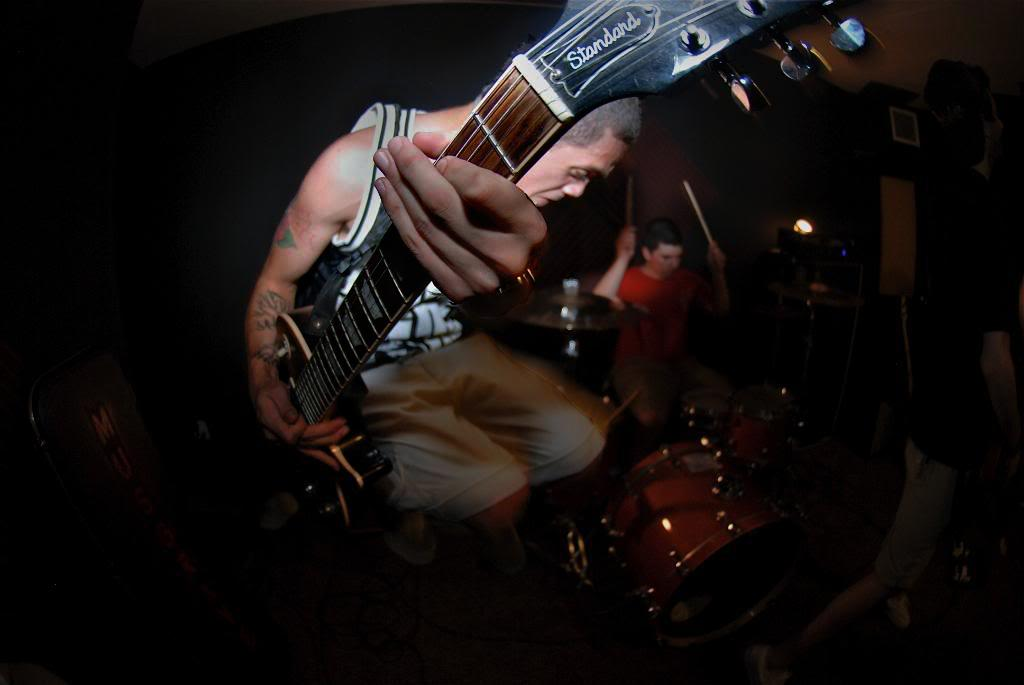What is the man in the image holding? The man in the image is holding a guitar. What is the other person in the image doing? The other person is playing a drum set. Can you describe the musical instruments in the image? The man is holding a guitar, and there is a drum set being played by another person. How does the stranger tie a knot in the water in the image? There is no stranger or water present in the image, and therefore no such activity can be observed. 